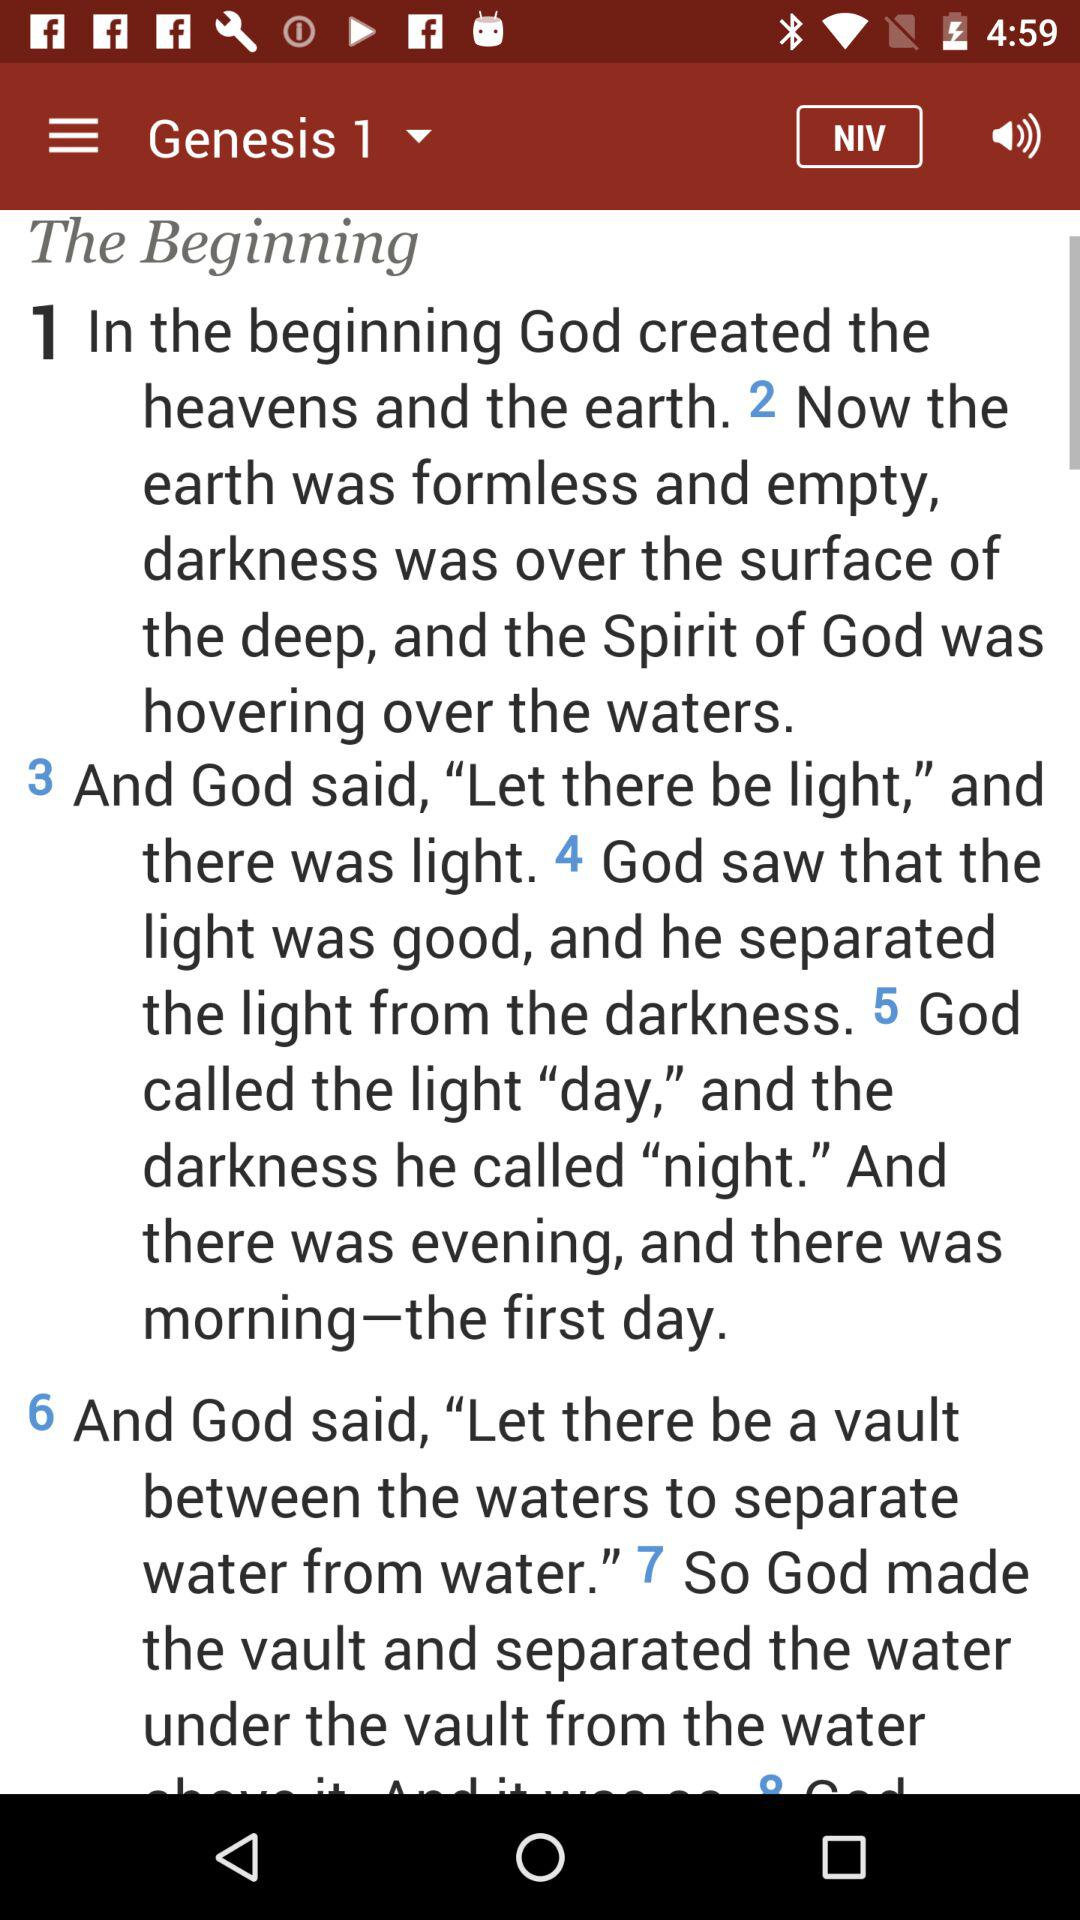Which chapter of Genesis is currently displayed? The currently displayed chapter of Genesis is 1. 